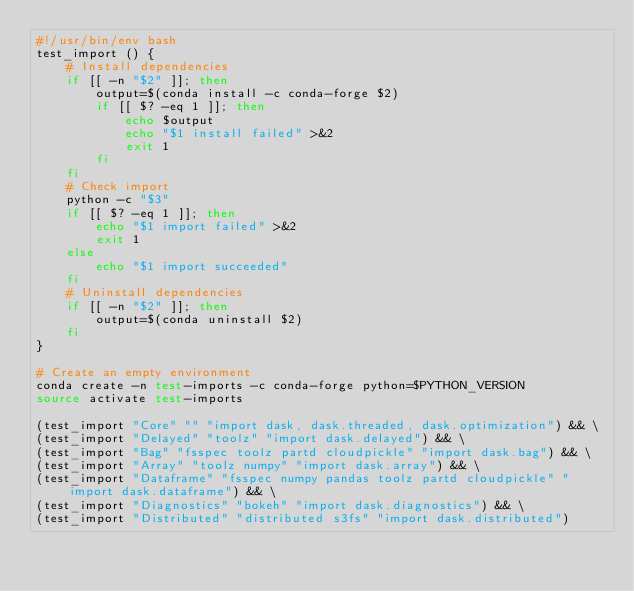Convert code to text. <code><loc_0><loc_0><loc_500><loc_500><_Bash_>#!/usr/bin/env bash
test_import () {
    # Install dependencies
    if [[ -n "$2" ]]; then
        output=$(conda install -c conda-forge $2)
        if [[ $? -eq 1 ]]; then
            echo $output
            echo "$1 install failed" >&2
            exit 1
        fi
    fi
    # Check import
    python -c "$3"
    if [[ $? -eq 1 ]]; then
        echo "$1 import failed" >&2
        exit 1
    else
        echo "$1 import succeeded"
    fi
    # Uninstall dependencies
    if [[ -n "$2" ]]; then
        output=$(conda uninstall $2)
    fi
}

# Create an empty environment
conda create -n test-imports -c conda-forge python=$PYTHON_VERSION
source activate test-imports

(test_import "Core" "" "import dask, dask.threaded, dask.optimization") && \
(test_import "Delayed" "toolz" "import dask.delayed") && \
(test_import "Bag" "fsspec toolz partd cloudpickle" "import dask.bag") && \
(test_import "Array" "toolz numpy" "import dask.array") && \
(test_import "Dataframe" "fsspec numpy pandas toolz partd cloudpickle" "import dask.dataframe") && \
(test_import "Diagnostics" "bokeh" "import dask.diagnostics") && \
(test_import "Distributed" "distributed s3fs" "import dask.distributed")
</code> 